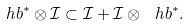Convert formula to latex. <formula><loc_0><loc_0><loc_500><loc_500>\ h b ^ { * } \otimes \mathcal { I } \subset \mathcal { I } + \mathcal { I } \otimes \ h b ^ { * } .</formula> 